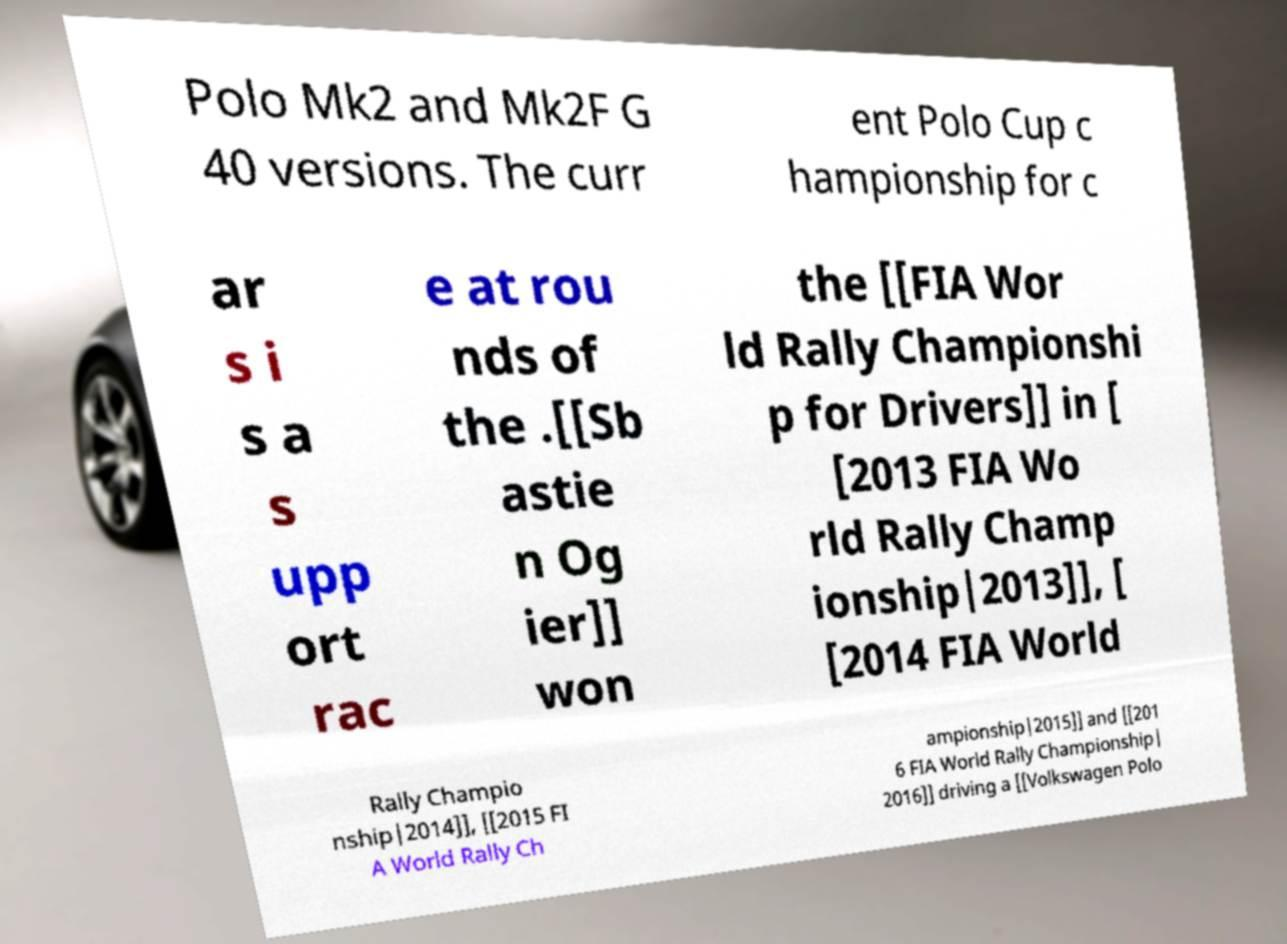Please identify and transcribe the text found in this image. Polo Mk2 and Mk2F G 40 versions. The curr ent Polo Cup c hampionship for c ar s i s a s upp ort rac e at rou nds of the .[[Sb astie n Og ier]] won the [[FIA Wor ld Rally Championshi p for Drivers]] in [ [2013 FIA Wo rld Rally Champ ionship|2013]], [ [2014 FIA World Rally Champio nship|2014]], [[2015 FI A World Rally Ch ampionship|2015]] and [[201 6 FIA World Rally Championship| 2016]] driving a [[Volkswagen Polo 